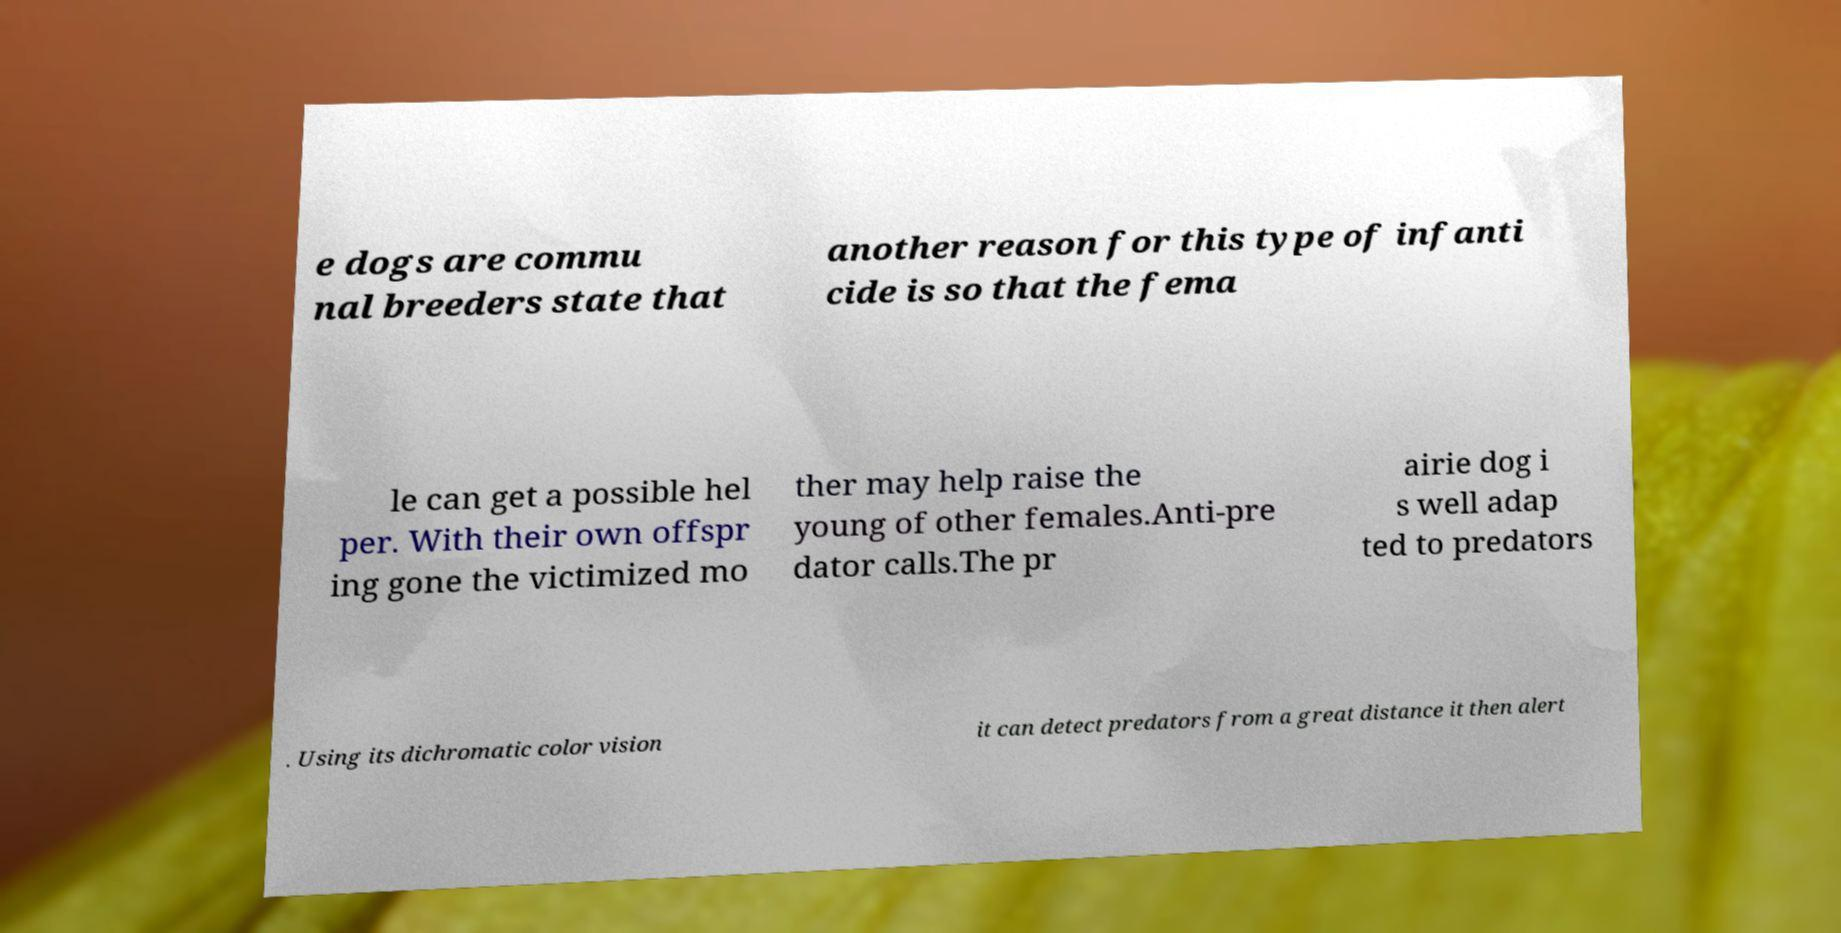Could you extract and type out the text from this image? e dogs are commu nal breeders state that another reason for this type of infanti cide is so that the fema le can get a possible hel per. With their own offspr ing gone the victimized mo ther may help raise the young of other females.Anti-pre dator calls.The pr airie dog i s well adap ted to predators . Using its dichromatic color vision it can detect predators from a great distance it then alert 